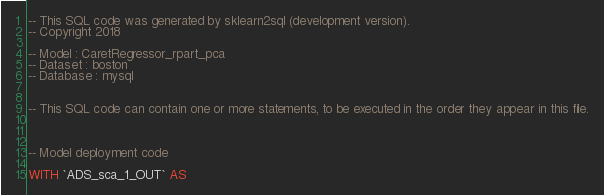<code> <loc_0><loc_0><loc_500><loc_500><_SQL_>-- This SQL code was generated by sklearn2sql (development version).
-- Copyright 2018

-- Model : CaretRegressor_rpart_pca
-- Dataset : boston
-- Database : mysql


-- This SQL code can contain one or more statements, to be executed in the order they appear in this file.



-- Model deployment code

WITH `ADS_sca_1_OUT` AS </code> 